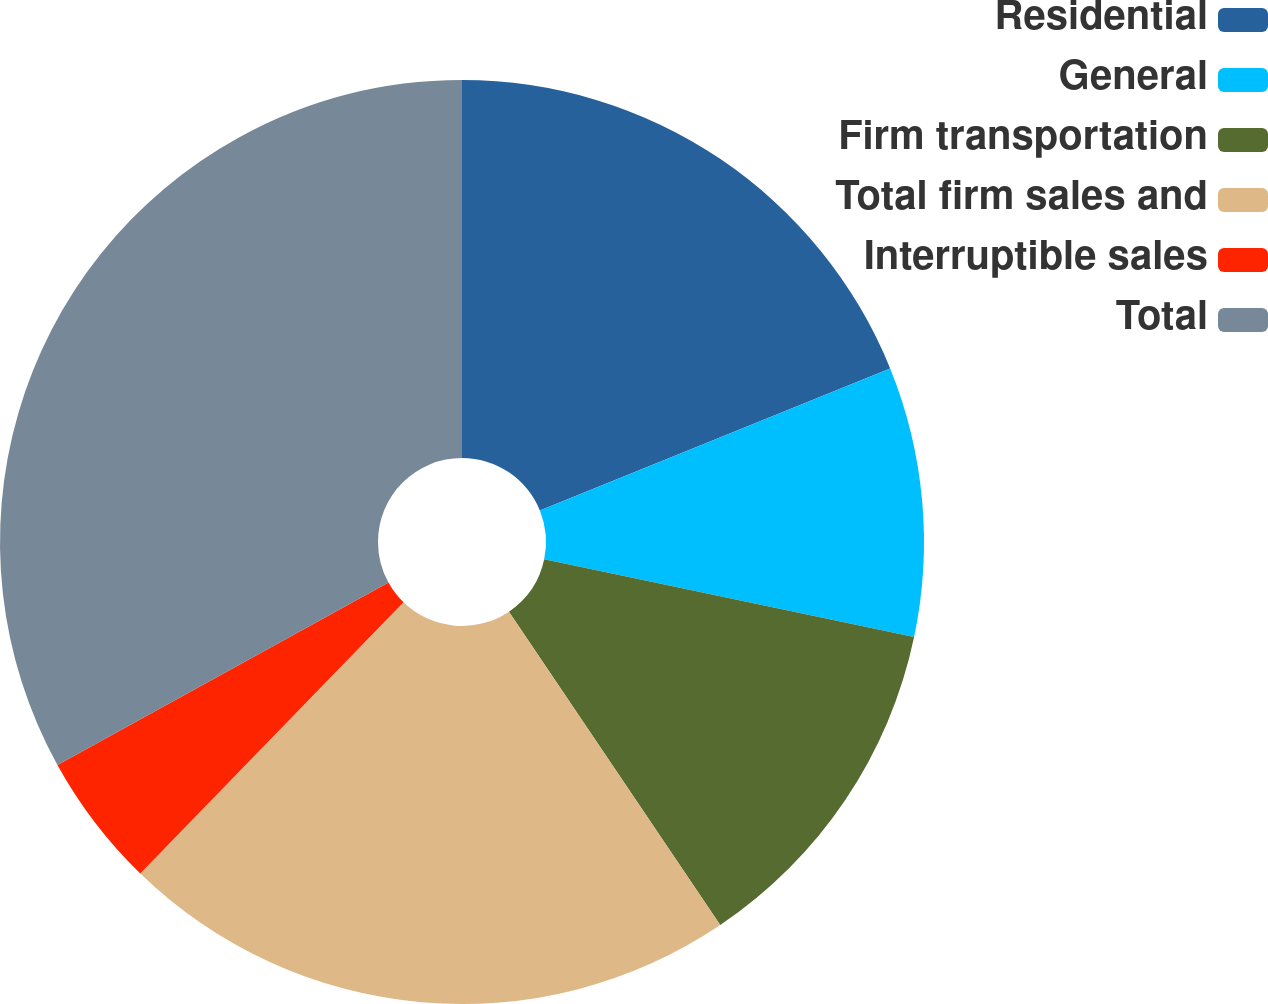<chart> <loc_0><loc_0><loc_500><loc_500><pie_chart><fcel>Residential<fcel>General<fcel>Firm transportation<fcel>Total firm sales and<fcel>Interruptible sales<fcel>Total<nl><fcel>18.87%<fcel>9.43%<fcel>12.26%<fcel>21.7%<fcel>4.72%<fcel>33.02%<nl></chart> 